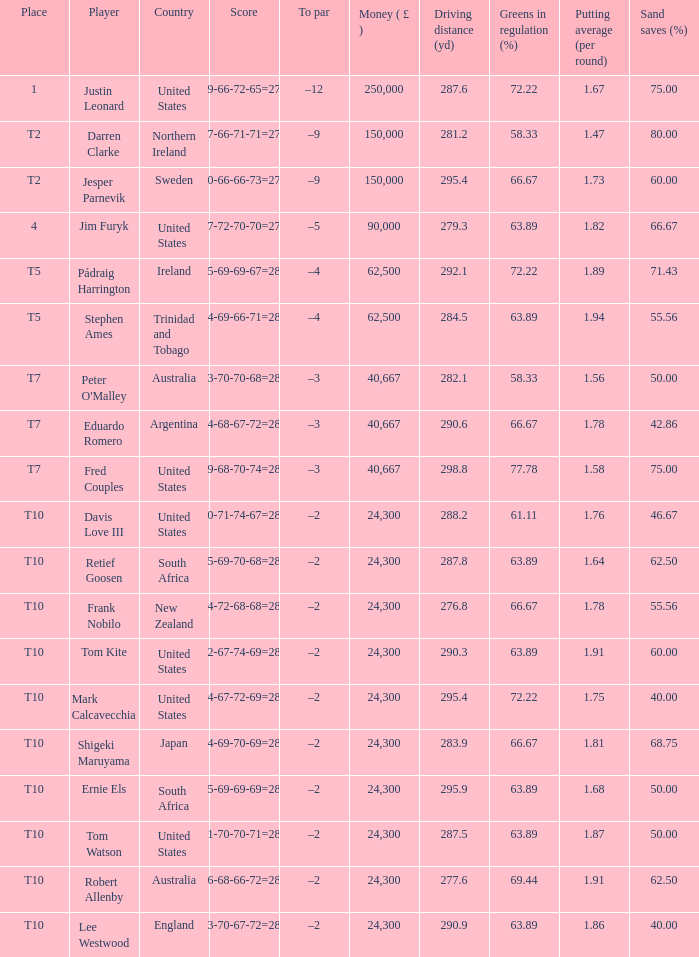How much money has been won by Stephen Ames? 62500.0. 